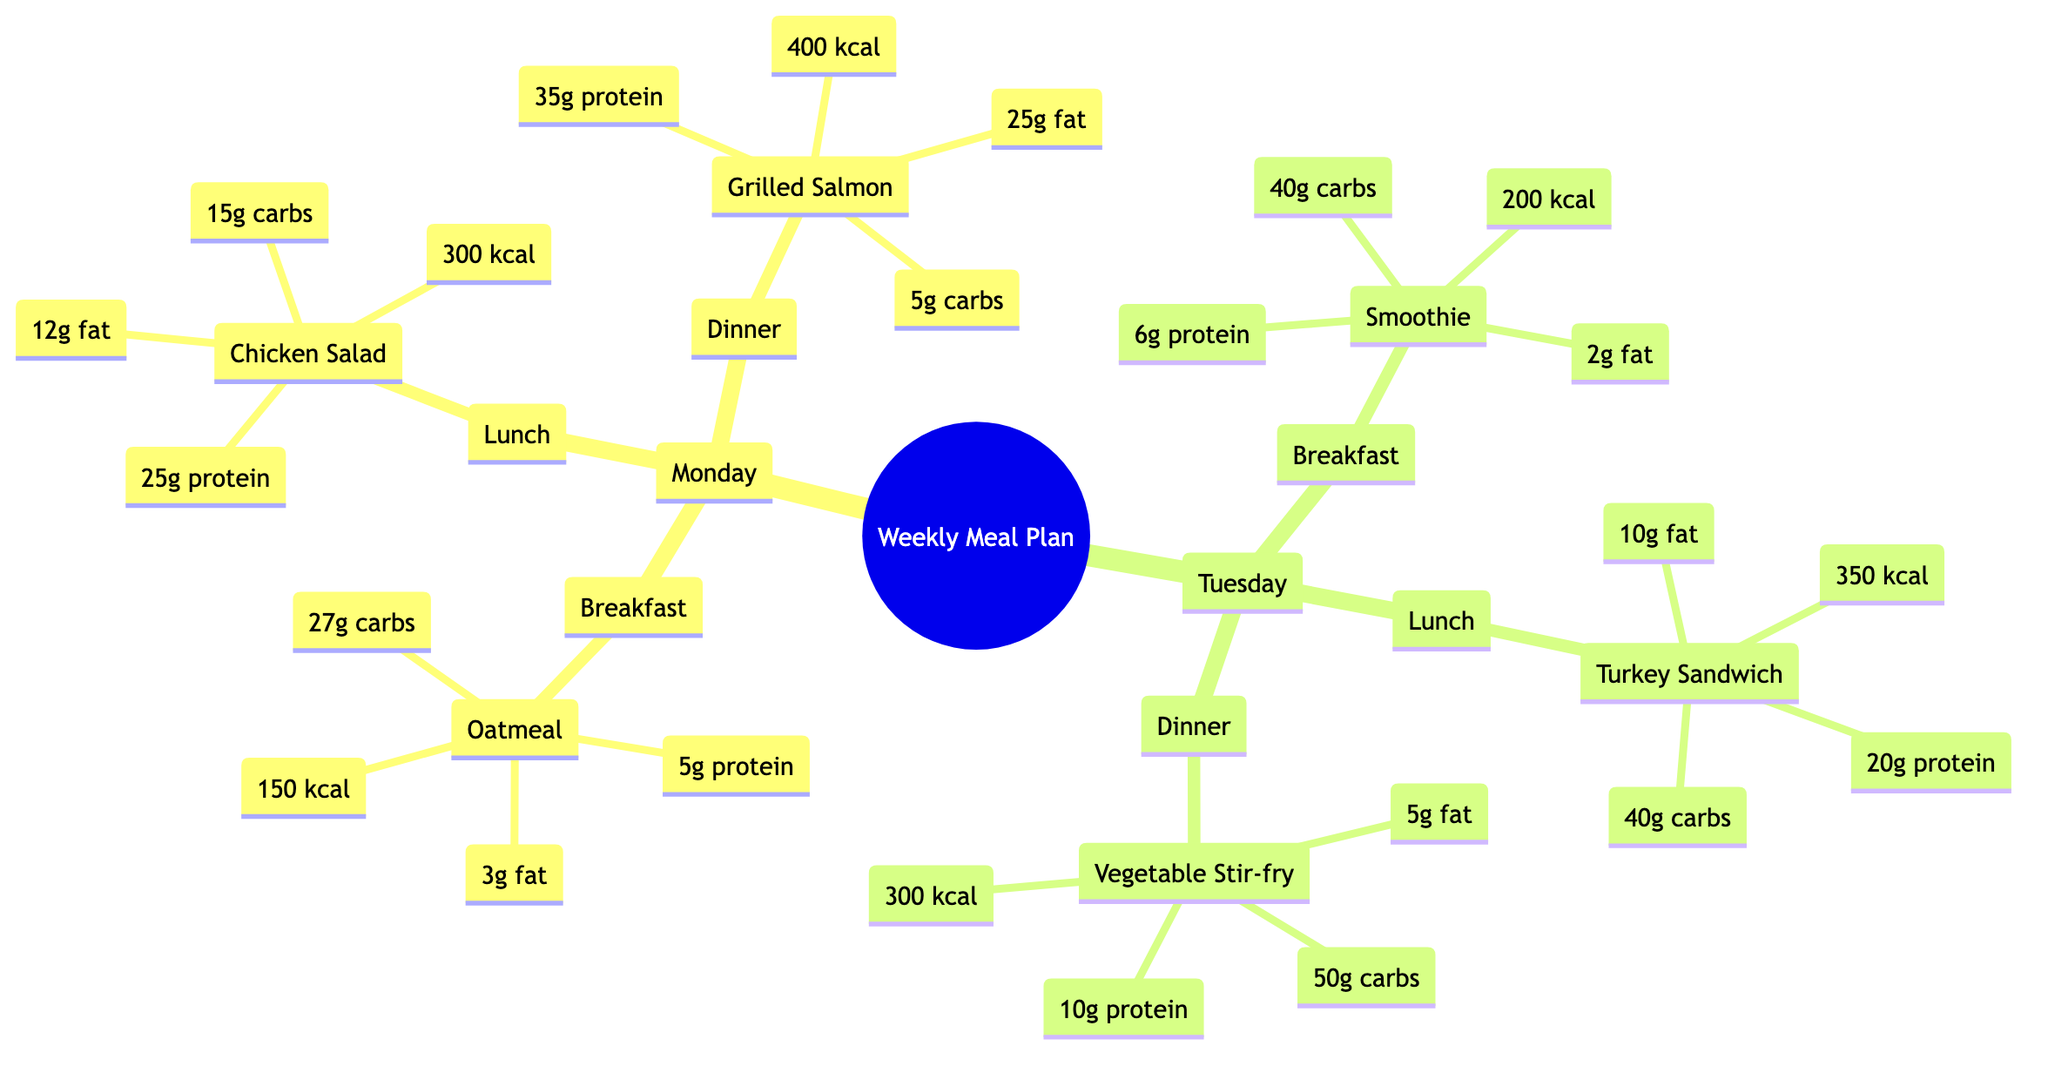What is the calorie count of the Grilled Salmon dinner? The Grilled Salmon dinner entry under Monday lists "400 kcal" as its calorie count.
Answer: 400 kcal How many meals are planned for Tuesday? Tuesday has three entries: Breakfast, Lunch, and Dinner, which totals to three meals.
Answer: 3 What is the total protein intake for Monday? The individual protein amounts for each meal on Monday are: 5g (Oatmeal) + 25g (Chicken Salad) + 35g (Grilled Salmon), which sums up to 65g.
Answer: 65g Which meal has the highest fat content on Tuesday? The fat content for Tuesday's meals is: Smoothie (2g) + Turkey Sandwich (10g) + Vegetable Stir-fry (5g). The Turkey Sandwich has the highest at 10g.
Answer: Turkey Sandwich What is the total carbohydrate intake for the whole week? For Monday: 27g (Oatmeal) + 15g (Chicken Salad) + 5g (Grilled Salmon) = 47g. For Tuesday: 40g (Smoothie) + 40g (Turkey Sandwich) + 50g (Vegetable Stir-fry) = 130g. Total = 47g + 130g = 177g.
Answer: 177g Which meal has the most protein on Monday? The protein values for Monday's meals are: Oatmeal (5g), Chicken Salad (25g), Grilled Salmon (35g). The Grilled Salmon has the highest protein at 35g.
Answer: Grilled Salmon What day features a Chicken Salad meal? The Chicken Salad meal is part of Monday's meal plan.
Answer: Monday How many grams of carbs does the Vegetable Stir-fry contain? The Vegetable Stir-fry meal on Tuesday is listed with "50g carbs," which indicates its carbohydrate content.
Answer: 50g carbs What is the combination of meals on Tuesday? Tuesday includes a Smoothie for breakfast, a Turkey Sandwich for lunch, and a Vegetable Stir-fry for dinner. This is the complete meal combination for Tuesday.
Answer: Smoothie, Turkey Sandwich, Vegetable Stir-fry 